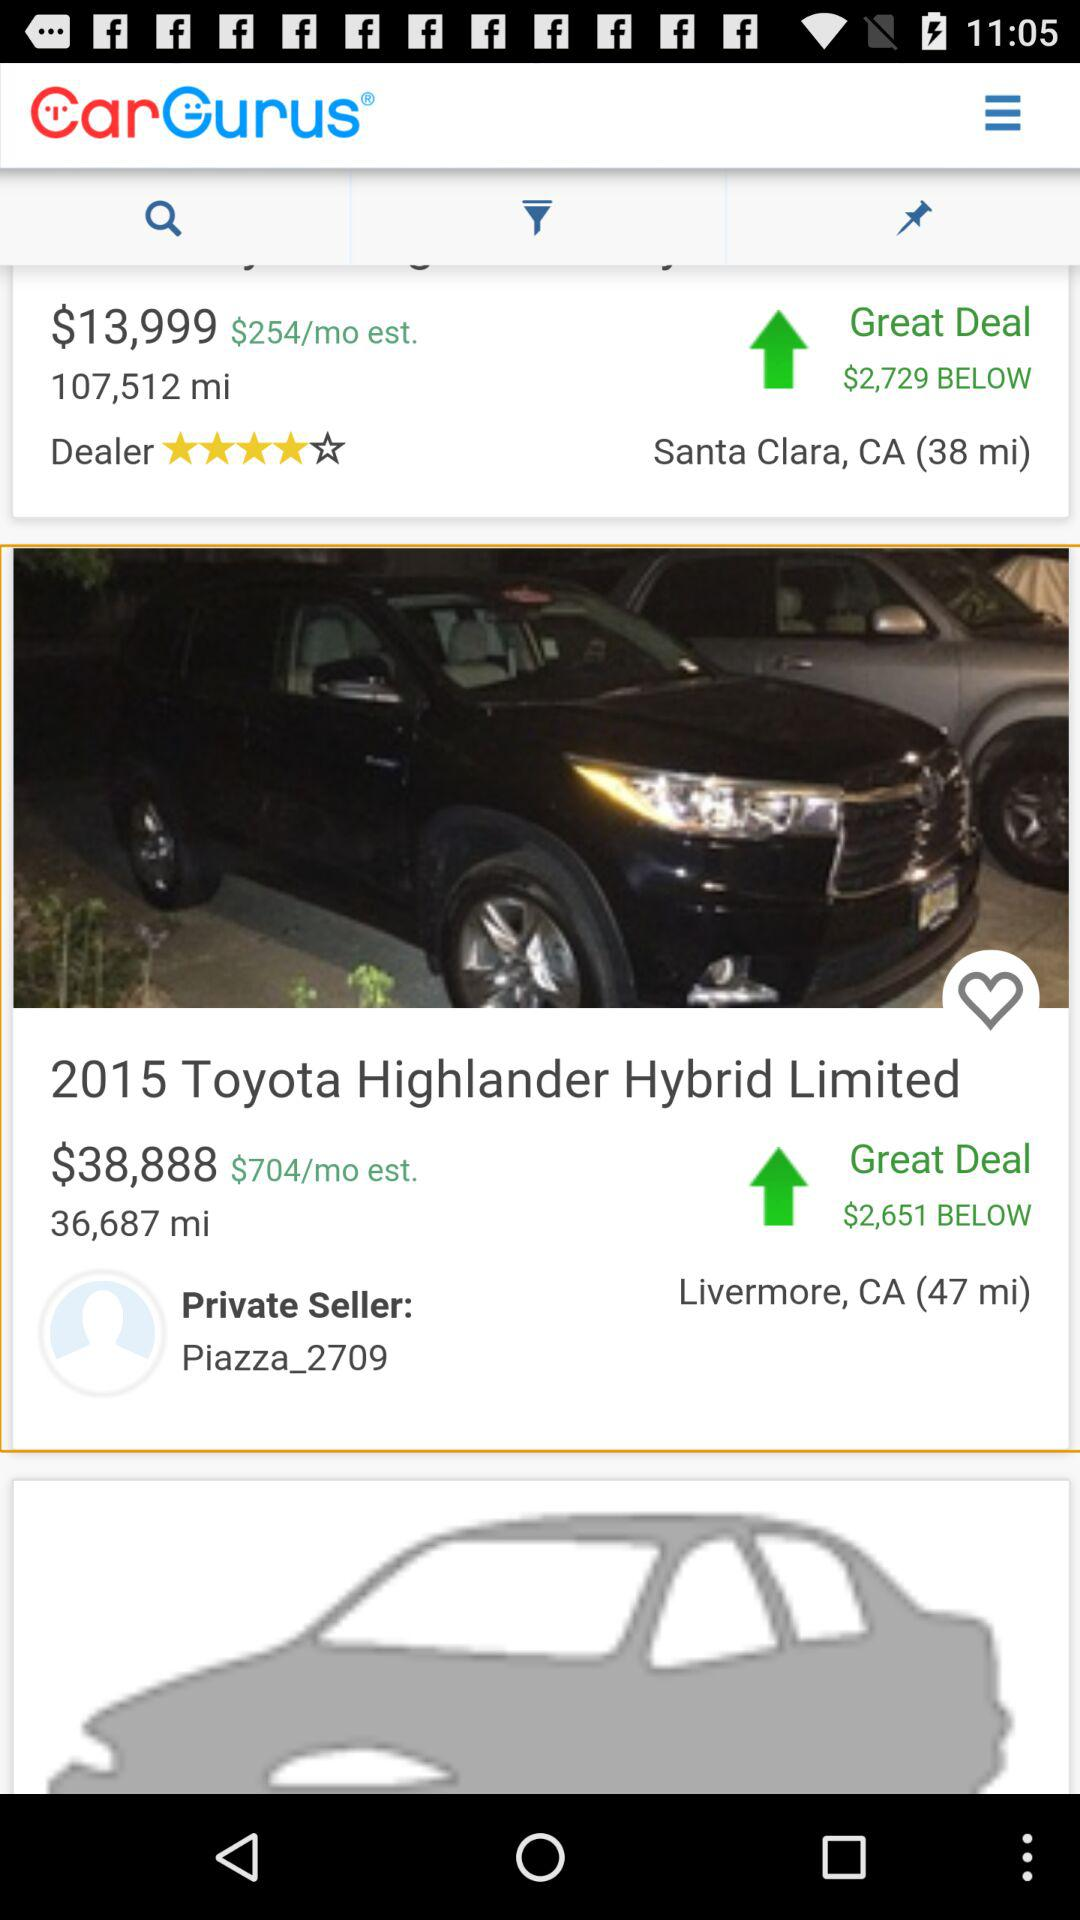What is the dealer rating? The dealer rating is 4 stars. 